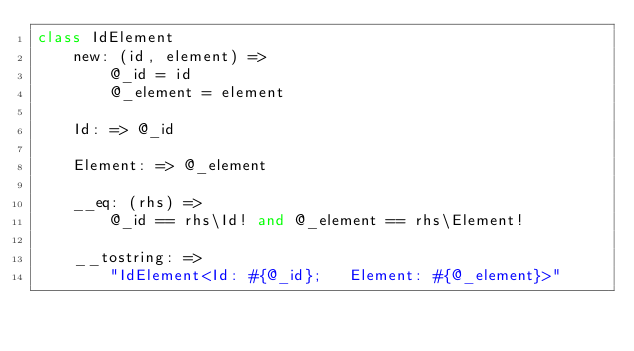Convert code to text. <code><loc_0><loc_0><loc_500><loc_500><_MoonScript_>class IdElement
	new: (id, element) =>
		@_id = id
		@_element = element

	Id: => @_id

	Element: => @_element

	__eq: (rhs) =>
		@_id == rhs\Id! and @_element == rhs\Element!

	__tostring: =>
		"IdElement<Id: #{@_id};   Element: #{@_element}>"</code> 